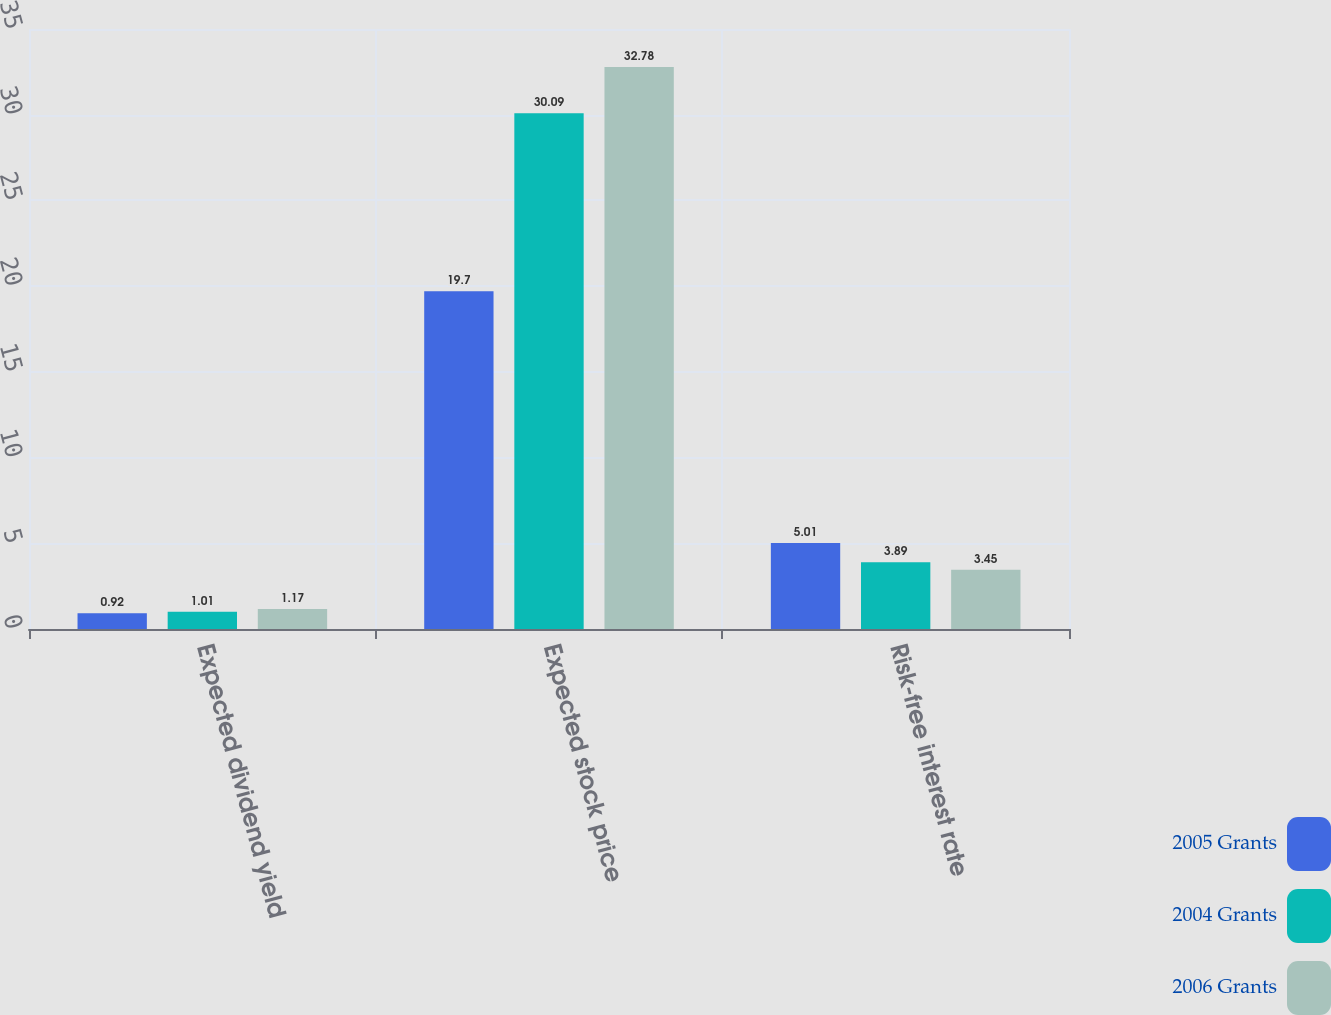Convert chart to OTSL. <chart><loc_0><loc_0><loc_500><loc_500><stacked_bar_chart><ecel><fcel>Expected dividend yield<fcel>Expected stock price<fcel>Risk-free interest rate<nl><fcel>2005 Grants<fcel>0.92<fcel>19.7<fcel>5.01<nl><fcel>2004 Grants<fcel>1.01<fcel>30.09<fcel>3.89<nl><fcel>2006 Grants<fcel>1.17<fcel>32.78<fcel>3.45<nl></chart> 